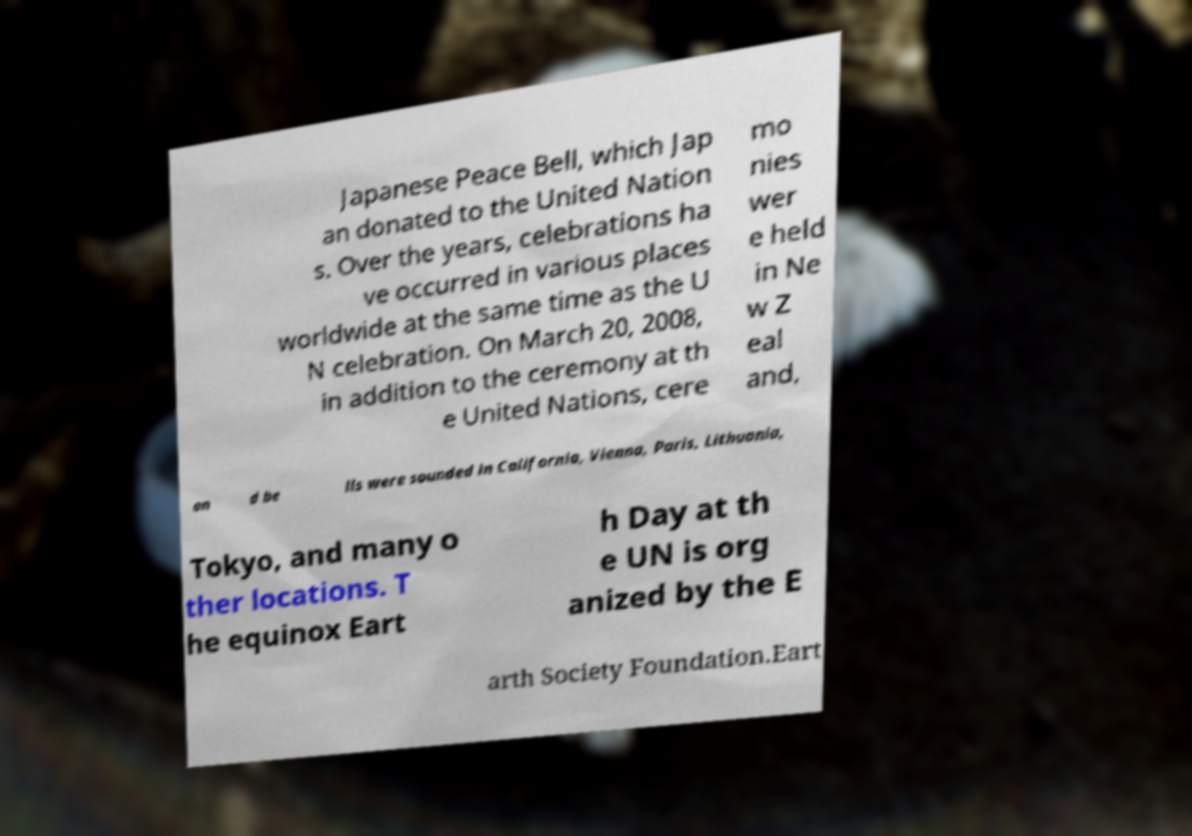Could you assist in decoding the text presented in this image and type it out clearly? Japanese Peace Bell, which Jap an donated to the United Nation s. Over the years, celebrations ha ve occurred in various places worldwide at the same time as the U N celebration. On March 20, 2008, in addition to the ceremony at th e United Nations, cere mo nies wer e held in Ne w Z eal and, an d be lls were sounded in California, Vienna, Paris, Lithuania, Tokyo, and many o ther locations. T he equinox Eart h Day at th e UN is org anized by the E arth Society Foundation.Eart 